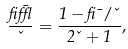Convert formula to latex. <formula><loc_0><loc_0><loc_500><loc_500>\frac { \beta { \bar { \epsilon } } } { \kappa } = \frac { 1 - \beta \mu / \kappa } { 2 \kappa + 1 } ,</formula> 